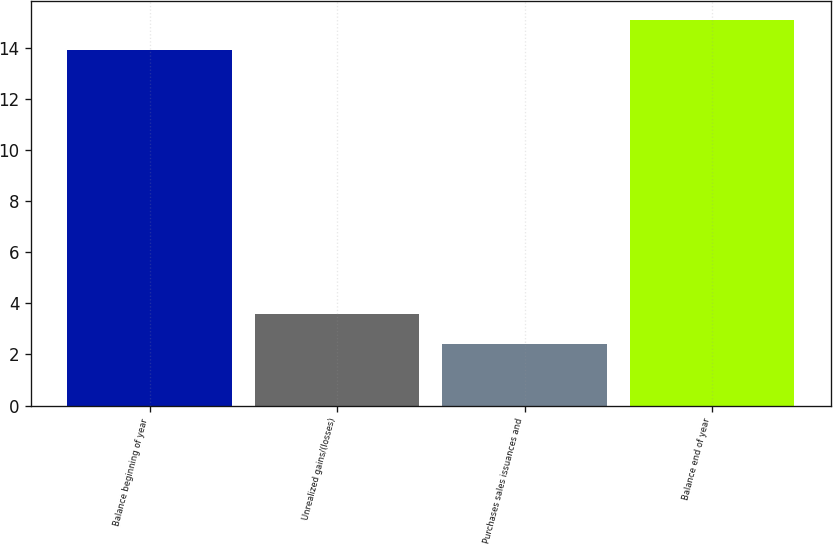<chart> <loc_0><loc_0><loc_500><loc_500><bar_chart><fcel>Balance beginning of year<fcel>Unrealized gains/(losses)<fcel>Purchases sales issuances and<fcel>Balance end of year<nl><fcel>13.9<fcel>3.58<fcel>2.4<fcel>15.08<nl></chart> 